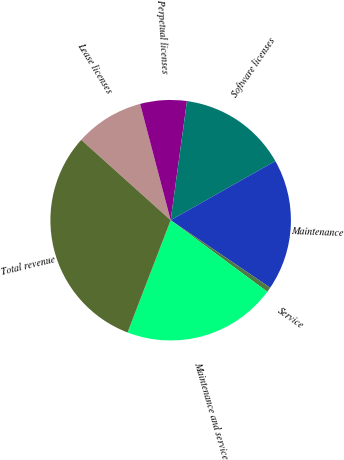Convert chart. <chart><loc_0><loc_0><loc_500><loc_500><pie_chart><fcel>Lease licenses<fcel>Perpetual licenses<fcel>Software licenses<fcel>Maintenance<fcel>Service<fcel>Maintenance and service<fcel>Total revenue<nl><fcel>9.27%<fcel>6.25%<fcel>14.65%<fcel>17.67%<fcel>0.66%<fcel>20.69%<fcel>30.81%<nl></chart> 